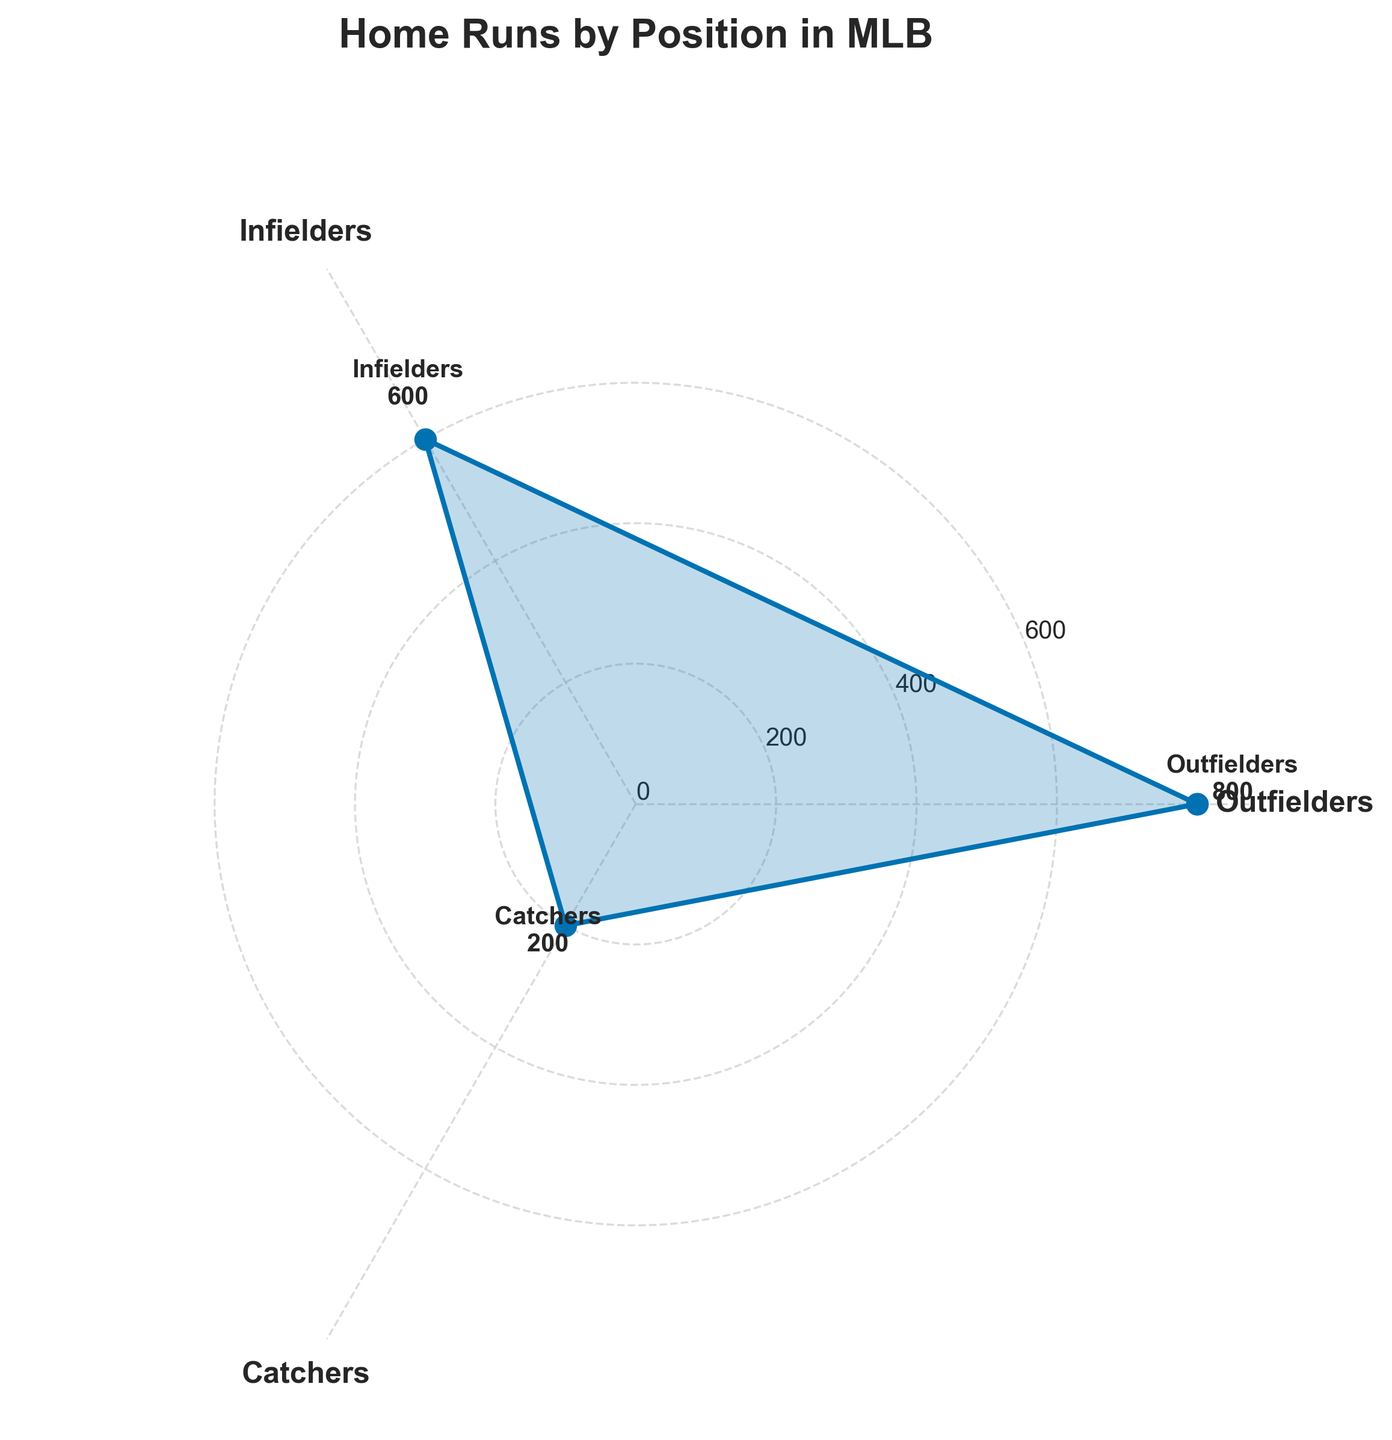What's the title of the figure? The title is usually at the top of the figure and in a larger or bolder font style to distinguish it from other text elements. In this case, it reads "Home Runs by Position in MLB."
Answer: Home Runs by Position in MLB Which position has the highest number of home runs? By looking at the length of the polar plot lines and the annotations, the Outfielders have the longest line, indicating the highest number of home runs.
Answer: Outfielders How many home runs are hit by Infielders and Catchers combined? We need to add the home runs of Infielders and Catchers. From the annotations, Infielders have 600 home runs, and Catchers have 200 home runs. Adding these together gives 600 + 200 = 800.
Answer: 800 Which position has fewer home runs: Infielders or Designated Hitters? By comparing the annotations, we see that Infielders have 600 home runs, while Designated Hitters are not in the top 3 visible groups. Therefore, Infielders have more home runs compared to Designated Hitters.
Answer: Designated Hitters Which position has the shortest line in the chart? In the polar plot, the shortest line corresponds to the position with the fewest home runs. The Catchers have the shortest line, indicating they have the fewest home runs.
Answer: Catchers What is the total number of home runs for all positions shown? Sum the home runs from all annotated positions: Outfielders (800), Infielders (600), and Catchers (200). So, 800 + 600 + 200 = 1600.
Answer: 1600 How many degrees apart are the positions on the Rose Chart? The Rose Chart uses angles to separate different positions. With 3 positions, each segment spans 360° / 3 = 120°.
Answer: 120° What is the average number of home runs for the positions shown? The sum of home runs for Outfielders, Infielders, and Catchers is 800 + 600 + 200 = 1600. There are 3 positions, so the average is 1600 / 3 ≈ 533.
Answer: 533 How many home runs more do Outfielders have than Infielders? Outfielders have 800 home runs and Infielders have 600. The difference is 800 - 600 = 200.
Answer: 200 Are the home runs of all positions evenly distributed? Looking at the lengths of the lines and the annotations, the lengths differ significantly, indicating an uneven distribution. Outfielders dominate with 800, while Catchers lag with 200.
Answer: No 